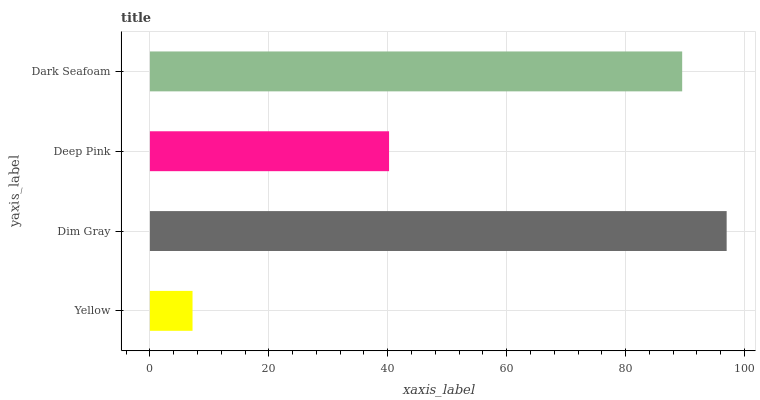Is Yellow the minimum?
Answer yes or no. Yes. Is Dim Gray the maximum?
Answer yes or no. Yes. Is Deep Pink the minimum?
Answer yes or no. No. Is Deep Pink the maximum?
Answer yes or no. No. Is Dim Gray greater than Deep Pink?
Answer yes or no. Yes. Is Deep Pink less than Dim Gray?
Answer yes or no. Yes. Is Deep Pink greater than Dim Gray?
Answer yes or no. No. Is Dim Gray less than Deep Pink?
Answer yes or no. No. Is Dark Seafoam the high median?
Answer yes or no. Yes. Is Deep Pink the low median?
Answer yes or no. Yes. Is Deep Pink the high median?
Answer yes or no. No. Is Yellow the low median?
Answer yes or no. No. 